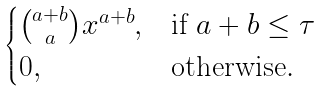<formula> <loc_0><loc_0><loc_500><loc_500>\begin{cases} \binom { a + b } { a } x ^ { a + b } , & \text {if $a+b\leq \tau$} \\ 0 , & \text {otherwise} . \end{cases}</formula> 